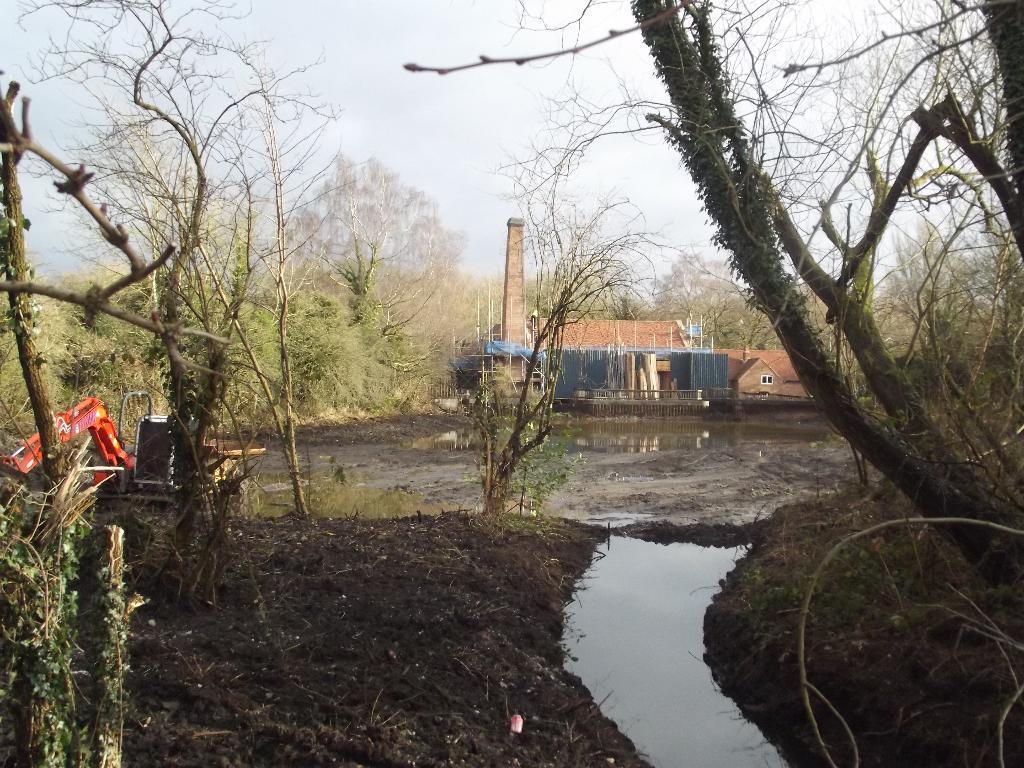How would you summarize this image in a sentence or two? In this picture I can observe some water. There are some trees and plants on the ground. I can observe house in the middle of the picture. In the background there is a sky. 